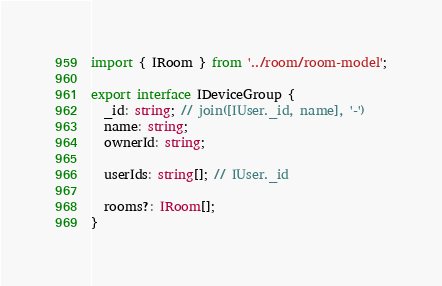<code> <loc_0><loc_0><loc_500><loc_500><_TypeScript_>import { IRoom } from '../room/room-model';

export interface IDeviceGroup {
  _id: string; // join([IUser._id, name], '-')
  name: string;
  ownerId: string;

  userIds: string[]; // IUser._id

  rooms?: IRoom[];
}
</code> 